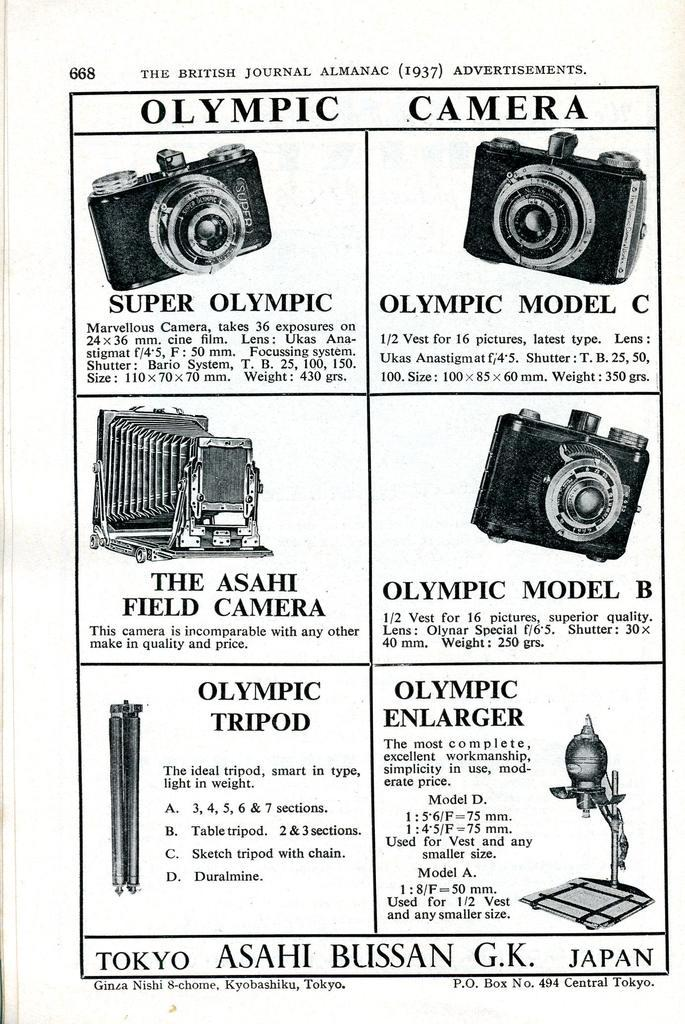What is present in the image that contains information? There is a paper in the image that contains information. What type of information is on the paper? The paper contains information about products. What color are the jeans being advertised on the paper? There is no mention of jeans or any specific product on the paper in the image, so we cannot determine the color of any jeans being advertised. 